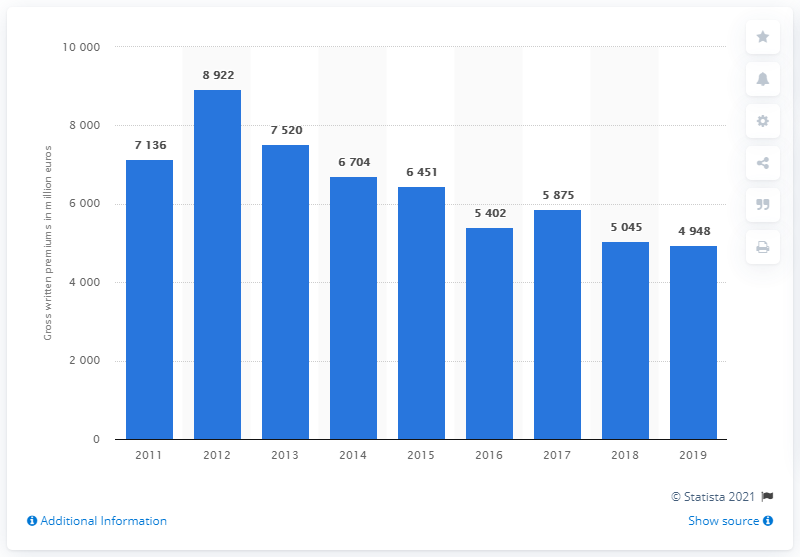Point out several critical features in this image. The sum of 2018 and 2019 is 9993. The year with the highest gross premiums is 2012. 